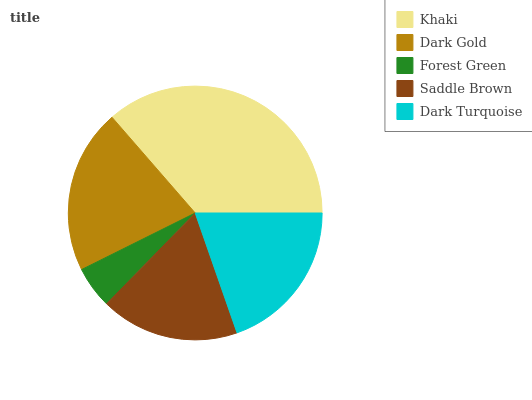Is Forest Green the minimum?
Answer yes or no. Yes. Is Khaki the maximum?
Answer yes or no. Yes. Is Dark Gold the minimum?
Answer yes or no. No. Is Dark Gold the maximum?
Answer yes or no. No. Is Khaki greater than Dark Gold?
Answer yes or no. Yes. Is Dark Gold less than Khaki?
Answer yes or no. Yes. Is Dark Gold greater than Khaki?
Answer yes or no. No. Is Khaki less than Dark Gold?
Answer yes or no. No. Is Dark Turquoise the high median?
Answer yes or no. Yes. Is Dark Turquoise the low median?
Answer yes or no. Yes. Is Saddle Brown the high median?
Answer yes or no. No. Is Khaki the low median?
Answer yes or no. No. 